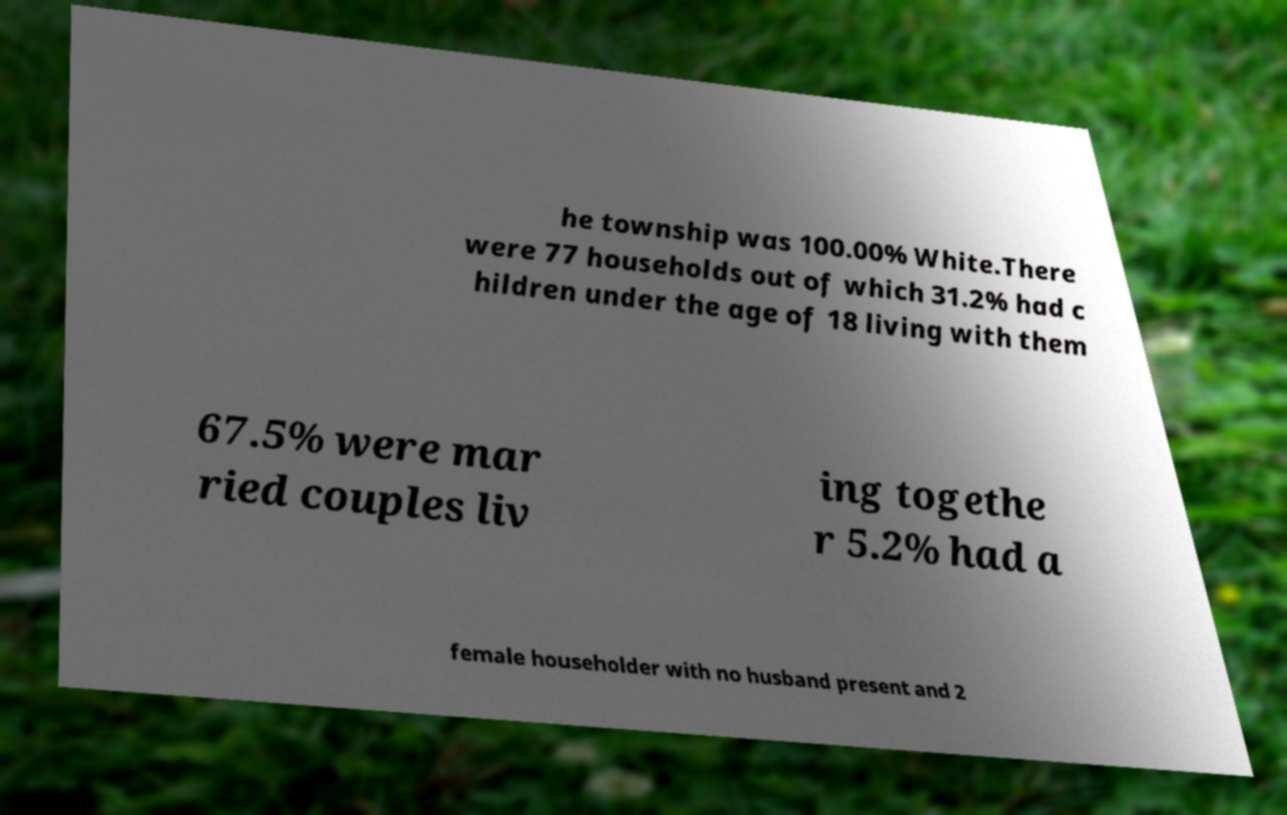For documentation purposes, I need the text within this image transcribed. Could you provide that? he township was 100.00% White.There were 77 households out of which 31.2% had c hildren under the age of 18 living with them 67.5% were mar ried couples liv ing togethe r 5.2% had a female householder with no husband present and 2 